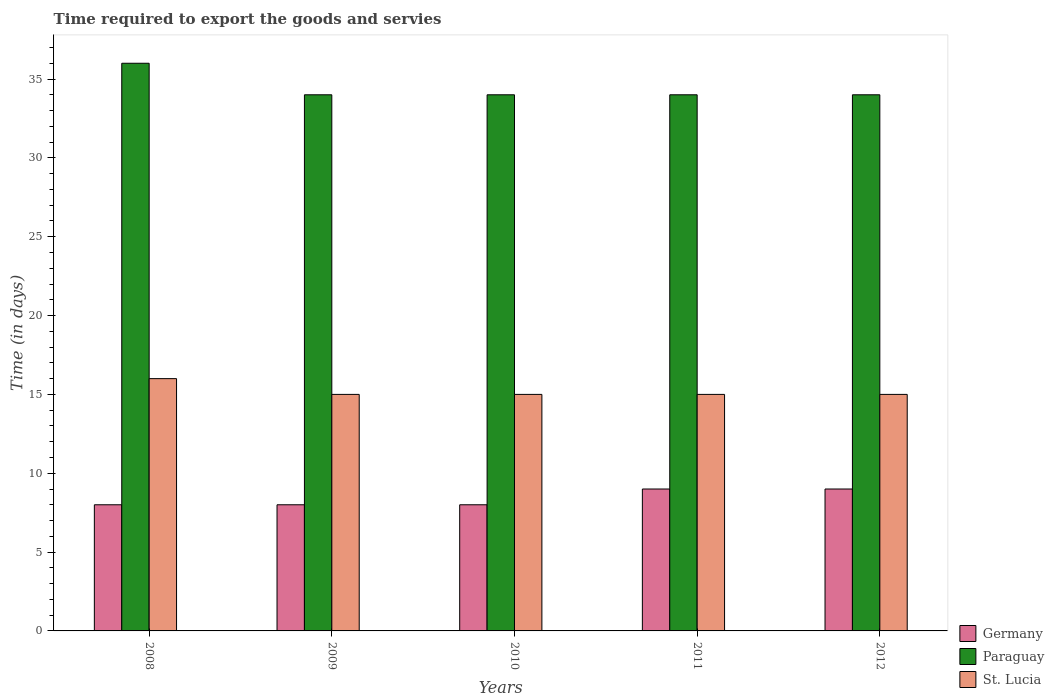How many different coloured bars are there?
Your answer should be very brief. 3. Are the number of bars per tick equal to the number of legend labels?
Offer a very short reply. Yes. How many bars are there on the 3rd tick from the right?
Your answer should be compact. 3. What is the label of the 4th group of bars from the left?
Provide a succinct answer. 2011. What is the number of days required to export the goods and services in Paraguay in 2012?
Keep it short and to the point. 34. Across all years, what is the maximum number of days required to export the goods and services in Germany?
Your response must be concise. 9. Across all years, what is the minimum number of days required to export the goods and services in St. Lucia?
Your answer should be compact. 15. In which year was the number of days required to export the goods and services in Germany maximum?
Your answer should be very brief. 2011. In which year was the number of days required to export the goods and services in Germany minimum?
Make the answer very short. 2008. What is the total number of days required to export the goods and services in St. Lucia in the graph?
Your answer should be very brief. 76. What is the difference between the number of days required to export the goods and services in Germany in 2011 and that in 2012?
Your response must be concise. 0. What is the difference between the number of days required to export the goods and services in St. Lucia in 2008 and the number of days required to export the goods and services in Germany in 2012?
Provide a short and direct response. 7. In the year 2009, what is the difference between the number of days required to export the goods and services in St. Lucia and number of days required to export the goods and services in Paraguay?
Your response must be concise. -19. What is the ratio of the number of days required to export the goods and services in St. Lucia in 2009 to that in 2010?
Provide a succinct answer. 1. Is the difference between the number of days required to export the goods and services in St. Lucia in 2010 and 2012 greater than the difference between the number of days required to export the goods and services in Paraguay in 2010 and 2012?
Provide a short and direct response. No. What is the difference between the highest and the lowest number of days required to export the goods and services in St. Lucia?
Provide a succinct answer. 1. In how many years, is the number of days required to export the goods and services in St. Lucia greater than the average number of days required to export the goods and services in St. Lucia taken over all years?
Your response must be concise. 1. Is the sum of the number of days required to export the goods and services in Paraguay in 2011 and 2012 greater than the maximum number of days required to export the goods and services in Germany across all years?
Make the answer very short. Yes. What does the 3rd bar from the left in 2010 represents?
Offer a very short reply. St. Lucia. What does the 3rd bar from the right in 2011 represents?
Your answer should be compact. Germany. Is it the case that in every year, the sum of the number of days required to export the goods and services in St. Lucia and number of days required to export the goods and services in Paraguay is greater than the number of days required to export the goods and services in Germany?
Provide a succinct answer. Yes. Are all the bars in the graph horizontal?
Provide a succinct answer. No. Are the values on the major ticks of Y-axis written in scientific E-notation?
Offer a very short reply. No. Does the graph contain grids?
Make the answer very short. No. How many legend labels are there?
Offer a very short reply. 3. What is the title of the graph?
Your response must be concise. Time required to export the goods and servies. What is the label or title of the X-axis?
Keep it short and to the point. Years. What is the label or title of the Y-axis?
Make the answer very short. Time (in days). What is the Time (in days) of Germany in 2008?
Provide a short and direct response. 8. What is the Time (in days) in St. Lucia in 2008?
Your answer should be very brief. 16. What is the Time (in days) in Paraguay in 2009?
Ensure brevity in your answer.  34. What is the Time (in days) of Germany in 2010?
Offer a very short reply. 8. What is the Time (in days) in Paraguay in 2010?
Ensure brevity in your answer.  34. What is the Time (in days) of Germany in 2011?
Provide a short and direct response. 9. What is the Time (in days) of Paraguay in 2011?
Offer a terse response. 34. What is the Time (in days) of St. Lucia in 2011?
Offer a terse response. 15. What is the Time (in days) in Germany in 2012?
Ensure brevity in your answer.  9. Across all years, what is the maximum Time (in days) of Germany?
Provide a succinct answer. 9. Across all years, what is the maximum Time (in days) in Paraguay?
Give a very brief answer. 36. Across all years, what is the minimum Time (in days) of Germany?
Ensure brevity in your answer.  8. What is the total Time (in days) in Germany in the graph?
Ensure brevity in your answer.  42. What is the total Time (in days) of Paraguay in the graph?
Ensure brevity in your answer.  172. What is the total Time (in days) of St. Lucia in the graph?
Offer a terse response. 76. What is the difference between the Time (in days) of St. Lucia in 2008 and that in 2009?
Keep it short and to the point. 1. What is the difference between the Time (in days) of Germany in 2008 and that in 2011?
Make the answer very short. -1. What is the difference between the Time (in days) of Germany in 2008 and that in 2012?
Offer a terse response. -1. What is the difference between the Time (in days) in Germany in 2009 and that in 2010?
Your response must be concise. 0. What is the difference between the Time (in days) in Paraguay in 2009 and that in 2010?
Your response must be concise. 0. What is the difference between the Time (in days) of St. Lucia in 2009 and that in 2010?
Give a very brief answer. 0. What is the difference between the Time (in days) of Germany in 2009 and that in 2011?
Your answer should be very brief. -1. What is the difference between the Time (in days) of Germany in 2009 and that in 2012?
Provide a succinct answer. -1. What is the difference between the Time (in days) of St. Lucia in 2009 and that in 2012?
Your answer should be very brief. 0. What is the difference between the Time (in days) of Germany in 2010 and that in 2011?
Offer a very short reply. -1. What is the difference between the Time (in days) of Paraguay in 2010 and that in 2011?
Offer a terse response. 0. What is the difference between the Time (in days) of St. Lucia in 2010 and that in 2011?
Provide a short and direct response. 0. What is the difference between the Time (in days) in Germany in 2010 and that in 2012?
Offer a very short reply. -1. What is the difference between the Time (in days) of Paraguay in 2010 and that in 2012?
Provide a succinct answer. 0. What is the difference between the Time (in days) of St. Lucia in 2010 and that in 2012?
Ensure brevity in your answer.  0. What is the difference between the Time (in days) of Germany in 2011 and that in 2012?
Make the answer very short. 0. What is the difference between the Time (in days) in St. Lucia in 2011 and that in 2012?
Your answer should be compact. 0. What is the difference between the Time (in days) of Germany in 2008 and the Time (in days) of Paraguay in 2009?
Offer a terse response. -26. What is the difference between the Time (in days) of Germany in 2008 and the Time (in days) of St. Lucia in 2009?
Your answer should be very brief. -7. What is the difference between the Time (in days) of Paraguay in 2008 and the Time (in days) of St. Lucia in 2009?
Provide a short and direct response. 21. What is the difference between the Time (in days) of Germany in 2008 and the Time (in days) of Paraguay in 2010?
Your answer should be very brief. -26. What is the difference between the Time (in days) of Germany in 2008 and the Time (in days) of St. Lucia in 2010?
Your answer should be very brief. -7. What is the difference between the Time (in days) of Germany in 2008 and the Time (in days) of St. Lucia in 2011?
Your response must be concise. -7. What is the difference between the Time (in days) in Paraguay in 2008 and the Time (in days) in St. Lucia in 2012?
Your answer should be compact. 21. What is the difference between the Time (in days) of Germany in 2009 and the Time (in days) of St. Lucia in 2010?
Your response must be concise. -7. What is the difference between the Time (in days) of Paraguay in 2009 and the Time (in days) of St. Lucia in 2010?
Offer a terse response. 19. What is the difference between the Time (in days) in Germany in 2009 and the Time (in days) in Paraguay in 2011?
Your answer should be very brief. -26. What is the difference between the Time (in days) in Paraguay in 2009 and the Time (in days) in St. Lucia in 2011?
Provide a succinct answer. 19. What is the difference between the Time (in days) of Germany in 2010 and the Time (in days) of Paraguay in 2011?
Give a very brief answer. -26. What is the difference between the Time (in days) of Paraguay in 2010 and the Time (in days) of St. Lucia in 2011?
Provide a succinct answer. 19. What is the difference between the Time (in days) of Germany in 2010 and the Time (in days) of St. Lucia in 2012?
Provide a short and direct response. -7. What is the difference between the Time (in days) in Paraguay in 2010 and the Time (in days) in St. Lucia in 2012?
Offer a terse response. 19. What is the difference between the Time (in days) in Germany in 2011 and the Time (in days) in Paraguay in 2012?
Ensure brevity in your answer.  -25. What is the difference between the Time (in days) of Germany in 2011 and the Time (in days) of St. Lucia in 2012?
Ensure brevity in your answer.  -6. What is the average Time (in days) in Germany per year?
Make the answer very short. 8.4. What is the average Time (in days) in Paraguay per year?
Offer a very short reply. 34.4. In the year 2008, what is the difference between the Time (in days) of Germany and Time (in days) of Paraguay?
Give a very brief answer. -28. In the year 2009, what is the difference between the Time (in days) in Paraguay and Time (in days) in St. Lucia?
Give a very brief answer. 19. In the year 2010, what is the difference between the Time (in days) in Germany and Time (in days) in St. Lucia?
Your answer should be compact. -7. In the year 2011, what is the difference between the Time (in days) in Paraguay and Time (in days) in St. Lucia?
Keep it short and to the point. 19. In the year 2012, what is the difference between the Time (in days) in Paraguay and Time (in days) in St. Lucia?
Provide a succinct answer. 19. What is the ratio of the Time (in days) of Paraguay in 2008 to that in 2009?
Provide a short and direct response. 1.06. What is the ratio of the Time (in days) of St. Lucia in 2008 to that in 2009?
Give a very brief answer. 1.07. What is the ratio of the Time (in days) in Paraguay in 2008 to that in 2010?
Offer a terse response. 1.06. What is the ratio of the Time (in days) in St. Lucia in 2008 to that in 2010?
Your response must be concise. 1.07. What is the ratio of the Time (in days) in Paraguay in 2008 to that in 2011?
Provide a short and direct response. 1.06. What is the ratio of the Time (in days) in St. Lucia in 2008 to that in 2011?
Keep it short and to the point. 1.07. What is the ratio of the Time (in days) in Paraguay in 2008 to that in 2012?
Make the answer very short. 1.06. What is the ratio of the Time (in days) of St. Lucia in 2008 to that in 2012?
Provide a succinct answer. 1.07. What is the ratio of the Time (in days) of Germany in 2009 to that in 2010?
Offer a terse response. 1. What is the ratio of the Time (in days) in Germany in 2009 to that in 2011?
Your response must be concise. 0.89. What is the ratio of the Time (in days) in Paraguay in 2009 to that in 2011?
Your response must be concise. 1. What is the ratio of the Time (in days) in St. Lucia in 2009 to that in 2011?
Your response must be concise. 1. What is the ratio of the Time (in days) in Germany in 2009 to that in 2012?
Ensure brevity in your answer.  0.89. What is the ratio of the Time (in days) of St. Lucia in 2009 to that in 2012?
Offer a terse response. 1. What is the ratio of the Time (in days) of Germany in 2010 to that in 2011?
Provide a short and direct response. 0.89. What is the ratio of the Time (in days) of Paraguay in 2010 to that in 2011?
Provide a succinct answer. 1. What is the ratio of the Time (in days) of Paraguay in 2011 to that in 2012?
Ensure brevity in your answer.  1. What is the difference between the highest and the second highest Time (in days) of Germany?
Provide a short and direct response. 0. What is the difference between the highest and the second highest Time (in days) in Paraguay?
Provide a short and direct response. 2. What is the difference between the highest and the lowest Time (in days) of Germany?
Give a very brief answer. 1. What is the difference between the highest and the lowest Time (in days) in St. Lucia?
Your answer should be compact. 1. 